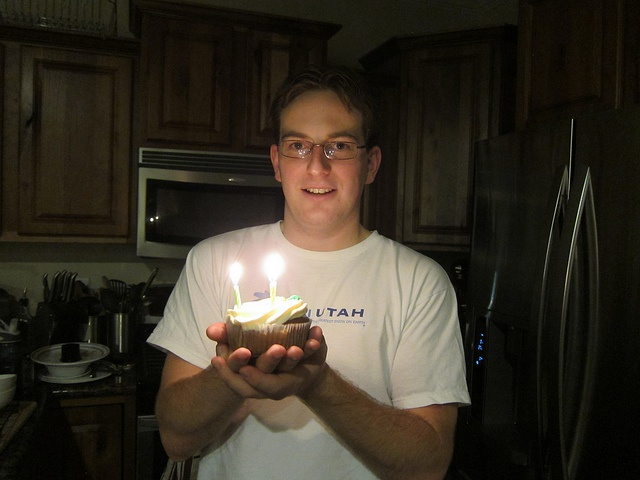Describe the objects in this image and their specific colors. I can see people in black, darkgray, maroon, and tan tones, refrigerator in black, gray, and darkgreen tones, microwave in black, darkgreen, and gray tones, cake in black, ivory, maroon, and khaki tones, and oven in black and gray tones in this image. 